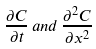<formula> <loc_0><loc_0><loc_500><loc_500>\frac { \partial C } { \partial t } \, a n d \, \frac { \partial ^ { 2 } C } { \partial x ^ { 2 } }</formula> 